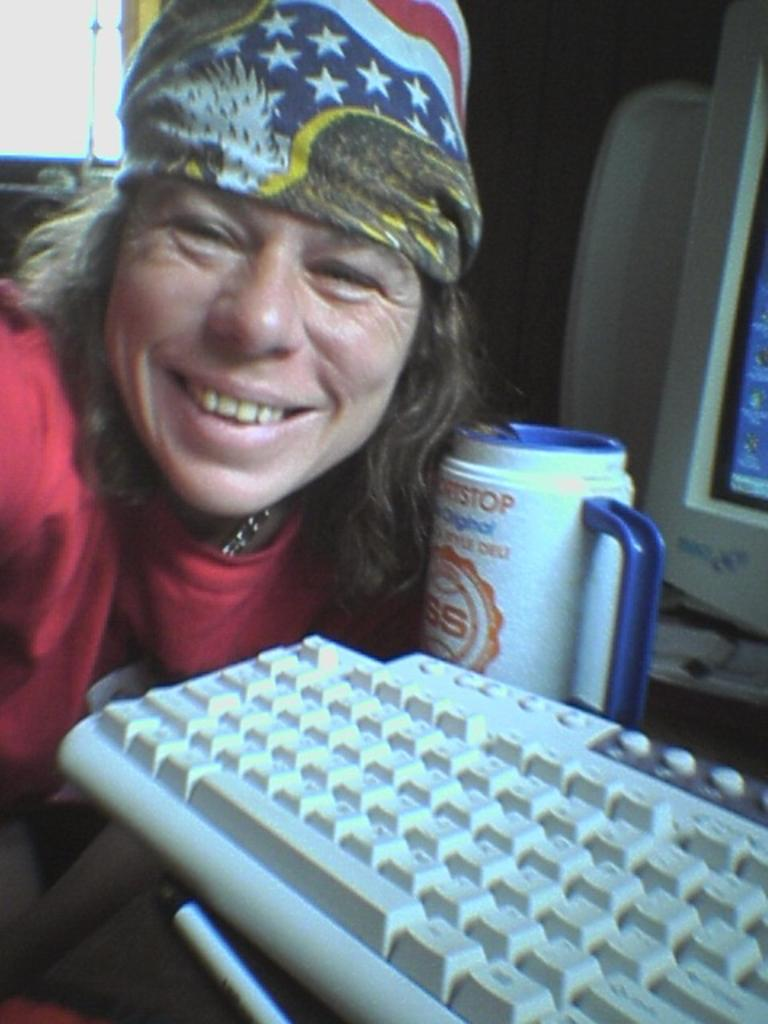Who is the main subject in the image? There is a lady in the center of the image. What object is visible near the lady? There is a keyboard in the image. Is there any other object present in the image? Yes, there is a mug in the image. What type of powder is being used on the board in the image? There is no board or powder present in the image. 